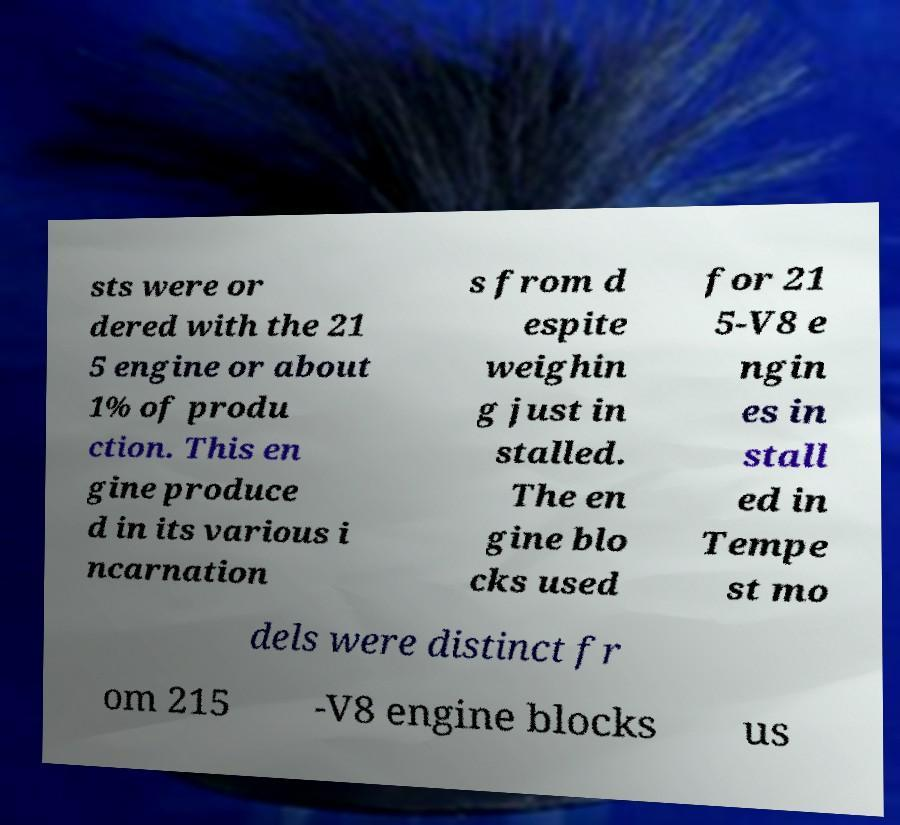For documentation purposes, I need the text within this image transcribed. Could you provide that? sts were or dered with the 21 5 engine or about 1% of produ ction. This en gine produce d in its various i ncarnation s from d espite weighin g just in stalled. The en gine blo cks used for 21 5-V8 e ngin es in stall ed in Tempe st mo dels were distinct fr om 215 -V8 engine blocks us 